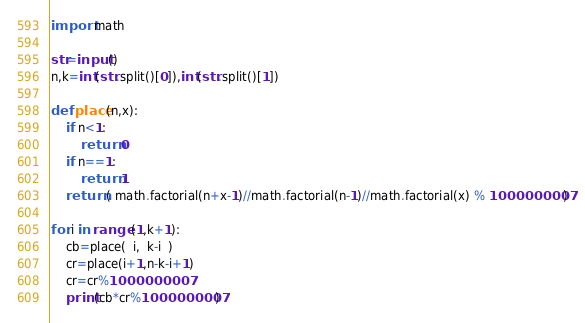<code> <loc_0><loc_0><loc_500><loc_500><_Python_>import math

str=input()
n,k=int(str.split()[0]),int(str.split()[1])

def place(n,x):
    if n<1:
        return 0
    if n==1:
        return 1
    return ( math.factorial(n+x-1)//math.factorial(n-1)//math.factorial(x) % 1000000007)

for i in range (1,k+1):
    cb=place(  i,  k-i  )
    cr=place(i+1,n-k-i+1)
    cr=cr%1000000007
    print(cb*cr%1000000007)
</code> 